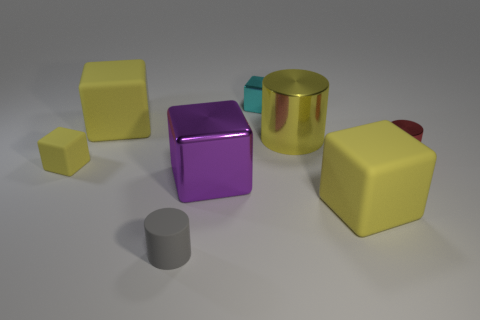Is there a block that has the same color as the big cylinder?
Your answer should be very brief. Yes. There is a tiny gray object that is the same shape as the big yellow metal object; what is it made of?
Your response must be concise. Rubber. Are there any objects to the left of the big yellow matte block in front of the small cylinder right of the tiny gray object?
Your answer should be very brief. Yes. There is a large yellow object that is in front of the yellow shiny object; is it the same shape as the big matte object on the left side of the cyan shiny object?
Offer a terse response. Yes. Is the number of yellow things that are in front of the large yellow cylinder greater than the number of small red shiny cylinders?
Your answer should be compact. Yes. What number of objects are either tiny matte objects or tiny yellow things?
Make the answer very short. 2. What color is the small matte cube?
Give a very brief answer. Yellow. How many other things are there of the same color as the big metal cube?
Offer a terse response. 0. Are there any yellow matte cubes right of the small gray cylinder?
Provide a short and direct response. Yes. There is a metal block in front of the small cube that is on the right side of the tiny matte thing that is left of the gray cylinder; what color is it?
Your answer should be compact. Purple. 